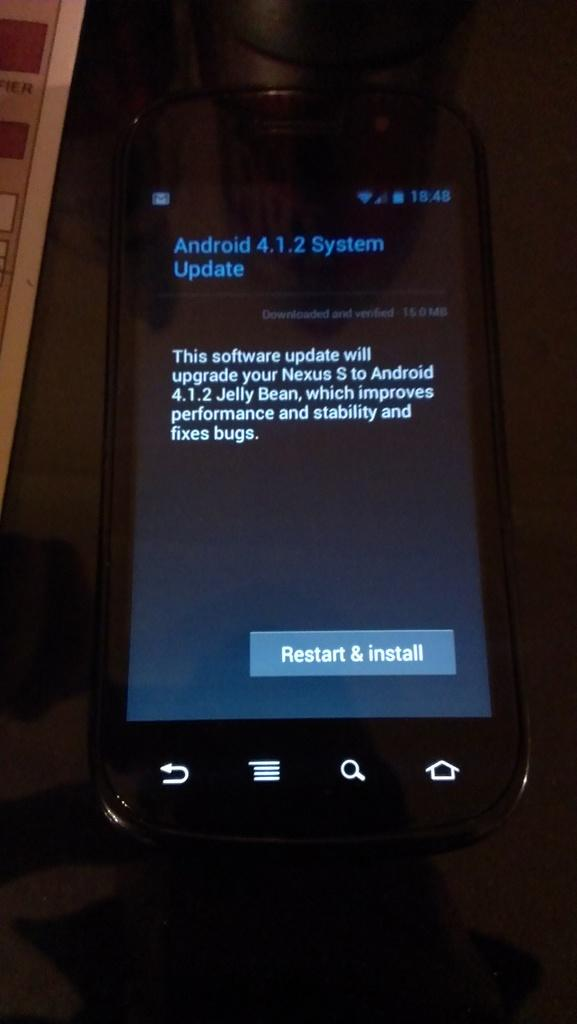Provide a one-sentence caption for the provided image. Black android phone that needs a system update. 